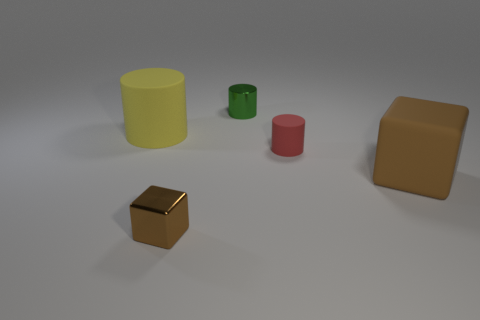Subtract all small green cylinders. How many cylinders are left? 2 Subtract all green cylinders. How many cylinders are left? 2 Subtract all blocks. How many objects are left? 3 Subtract all brown cubes. How many green cylinders are left? 1 Subtract all cyan cylinders. Subtract all gray spheres. How many cylinders are left? 3 Subtract all red rubber objects. Subtract all big matte cylinders. How many objects are left? 3 Add 3 big cylinders. How many big cylinders are left? 4 Add 3 red cylinders. How many red cylinders exist? 4 Add 1 small brown balls. How many objects exist? 6 Subtract 1 yellow cylinders. How many objects are left? 4 